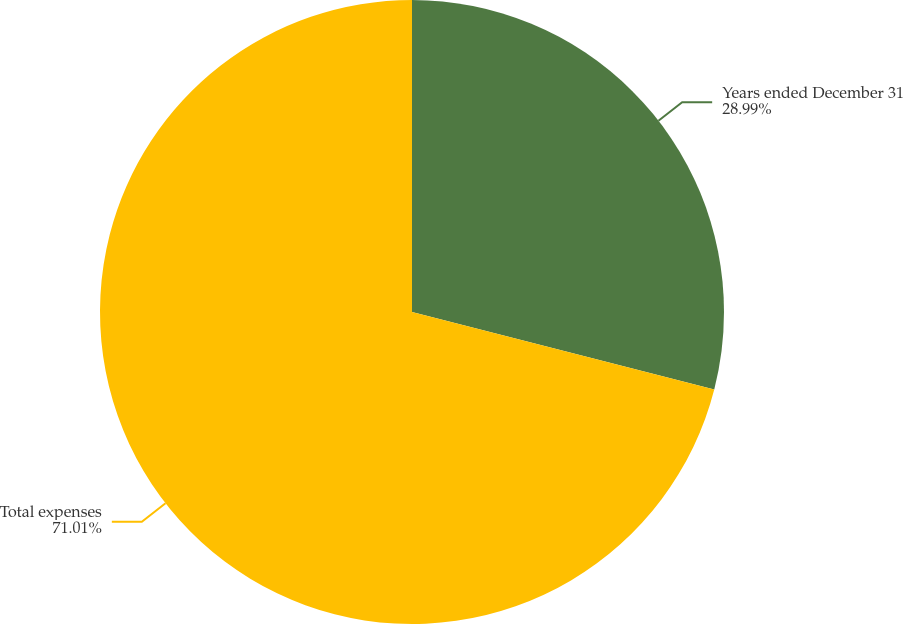<chart> <loc_0><loc_0><loc_500><loc_500><pie_chart><fcel>Years ended December 31<fcel>Total expenses<nl><fcel>28.99%<fcel>71.01%<nl></chart> 